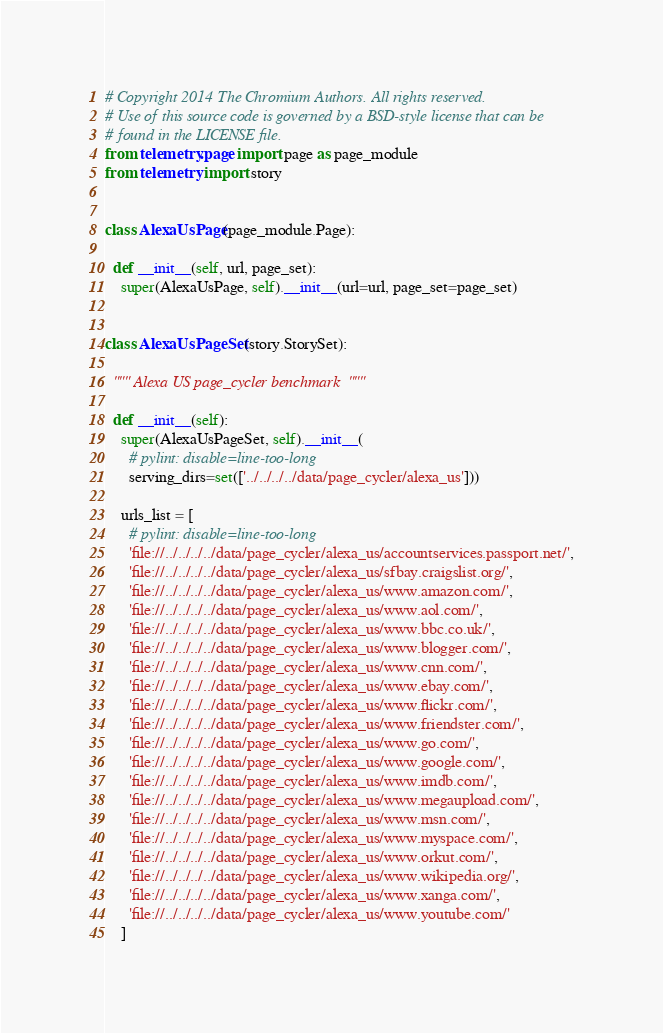Convert code to text. <code><loc_0><loc_0><loc_500><loc_500><_Python_># Copyright 2014 The Chromium Authors. All rights reserved.
# Use of this source code is governed by a BSD-style license that can be
# found in the LICENSE file.
from telemetry.page import page as page_module
from telemetry import story


class AlexaUsPage(page_module.Page):

  def __init__(self, url, page_set):
    super(AlexaUsPage, self).__init__(url=url, page_set=page_set)


class AlexaUsPageSet(story.StorySet):

  """ Alexa US page_cycler benchmark  """

  def __init__(self):
    super(AlexaUsPageSet, self).__init__(
      # pylint: disable=line-too-long
      serving_dirs=set(['../../../../data/page_cycler/alexa_us']))

    urls_list = [
      # pylint: disable=line-too-long
      'file://../../../../data/page_cycler/alexa_us/accountservices.passport.net/',
      'file://../../../../data/page_cycler/alexa_us/sfbay.craigslist.org/',
      'file://../../../../data/page_cycler/alexa_us/www.amazon.com/',
      'file://../../../../data/page_cycler/alexa_us/www.aol.com/',
      'file://../../../../data/page_cycler/alexa_us/www.bbc.co.uk/',
      'file://../../../../data/page_cycler/alexa_us/www.blogger.com/',
      'file://../../../../data/page_cycler/alexa_us/www.cnn.com/',
      'file://../../../../data/page_cycler/alexa_us/www.ebay.com/',
      'file://../../../../data/page_cycler/alexa_us/www.flickr.com/',
      'file://../../../../data/page_cycler/alexa_us/www.friendster.com/',
      'file://../../../../data/page_cycler/alexa_us/www.go.com/',
      'file://../../../../data/page_cycler/alexa_us/www.google.com/',
      'file://../../../../data/page_cycler/alexa_us/www.imdb.com/',
      'file://../../../../data/page_cycler/alexa_us/www.megaupload.com/',
      'file://../../../../data/page_cycler/alexa_us/www.msn.com/',
      'file://../../../../data/page_cycler/alexa_us/www.myspace.com/',
      'file://../../../../data/page_cycler/alexa_us/www.orkut.com/',
      'file://../../../../data/page_cycler/alexa_us/www.wikipedia.org/',
      'file://../../../../data/page_cycler/alexa_us/www.xanga.com/',
      'file://../../../../data/page_cycler/alexa_us/www.youtube.com/'
    ]
</code> 